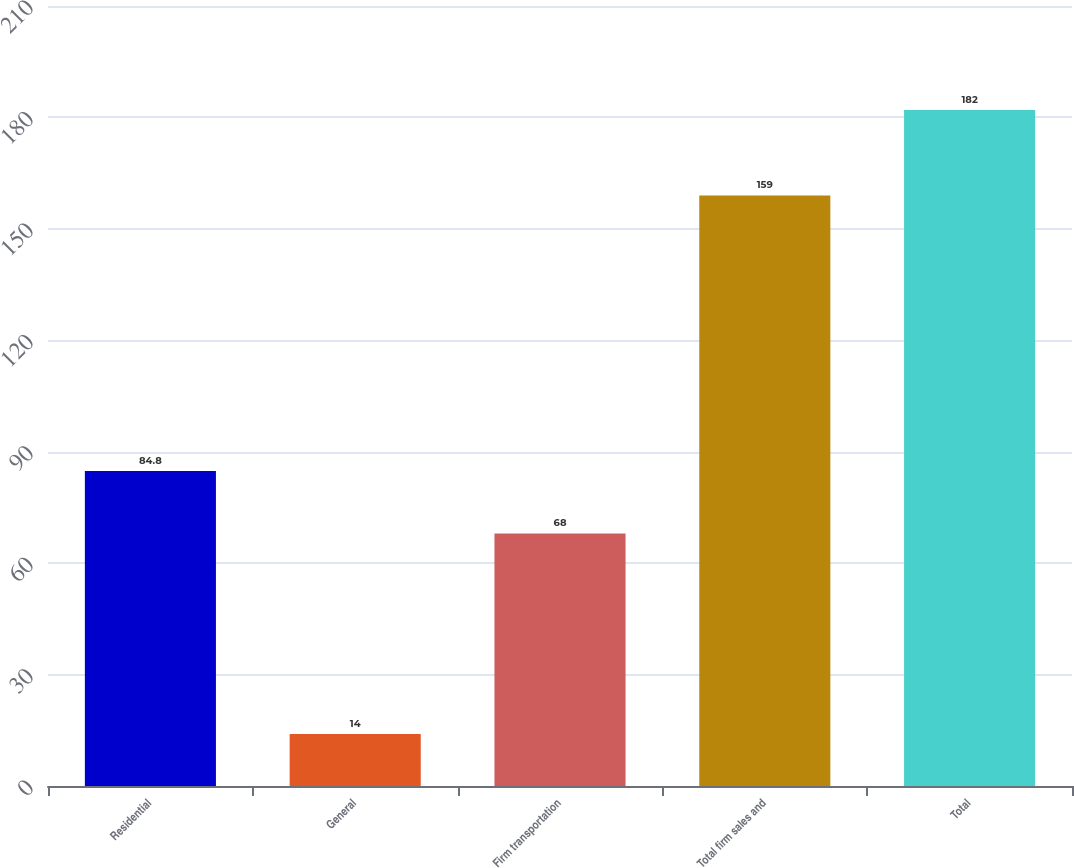Convert chart. <chart><loc_0><loc_0><loc_500><loc_500><bar_chart><fcel>Residential<fcel>General<fcel>Firm transportation<fcel>Total firm sales and<fcel>Total<nl><fcel>84.8<fcel>14<fcel>68<fcel>159<fcel>182<nl></chart> 